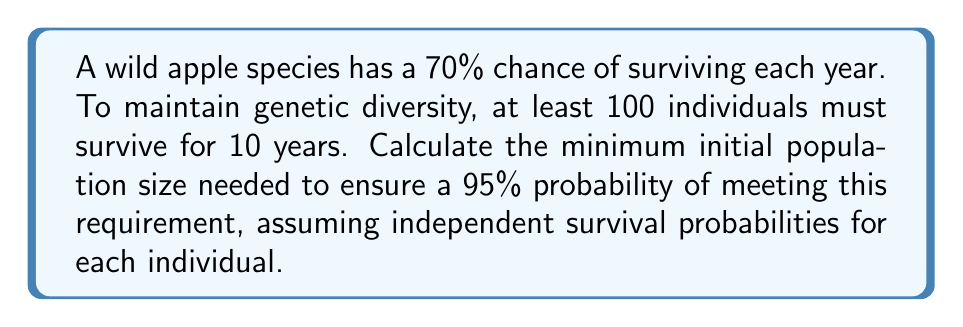Help me with this question. Let's approach this step-by-step:

1) First, we need to find the probability of an individual apple tree surviving for 10 years:
   $P(\text{10-year survival}) = 0.7^{10} \approx 0.0282$

2) We want at least 100 individuals to survive. This follows a binomial distribution, where n is the initial population size we're looking for, and p = 0.0282.

3) We need to find n such that:
   $P(X \geq 100) \geq 0.95$, where X ~ Bin(n, 0.0282)

4) This is equivalent to:
   $P(X < 100) \leq 0.05$

5) We can use the normal approximation to the binomial distribution:
   $X \sim N(np, np(1-p))$

6) Standardizing, we get:
   $P(\frac{X - np}{\sqrt{np(1-p)}} < \frac{99.5 - np}{\sqrt{np(1-p)}}) \leq 0.05$

7) The left side of the inequality corresponds to -1.645 in the standard normal distribution.

8) Therefore:
   $\frac{99.5 - np}{\sqrt{np(1-p)}} = -1.645$

9) Solving this equation:
   $99.5 - np = -1.645\sqrt{np(1-p)}$
   $(99.5 - np)^2 = 2.706np(1-p)$
   $9900.25 - 199np + n^2p^2 = 2.706np - 2.706np^2$
   $n^2p^2 + 2.706np^2 - 201.706np + 9900.25 = 0$

10) Substituting p = 0.0282 and solving this quadratic equation, we get:
    $n \approx 3893$

11) Since n must be an integer, we round up to ensure the probability is at least 95%.
Answer: 3894 